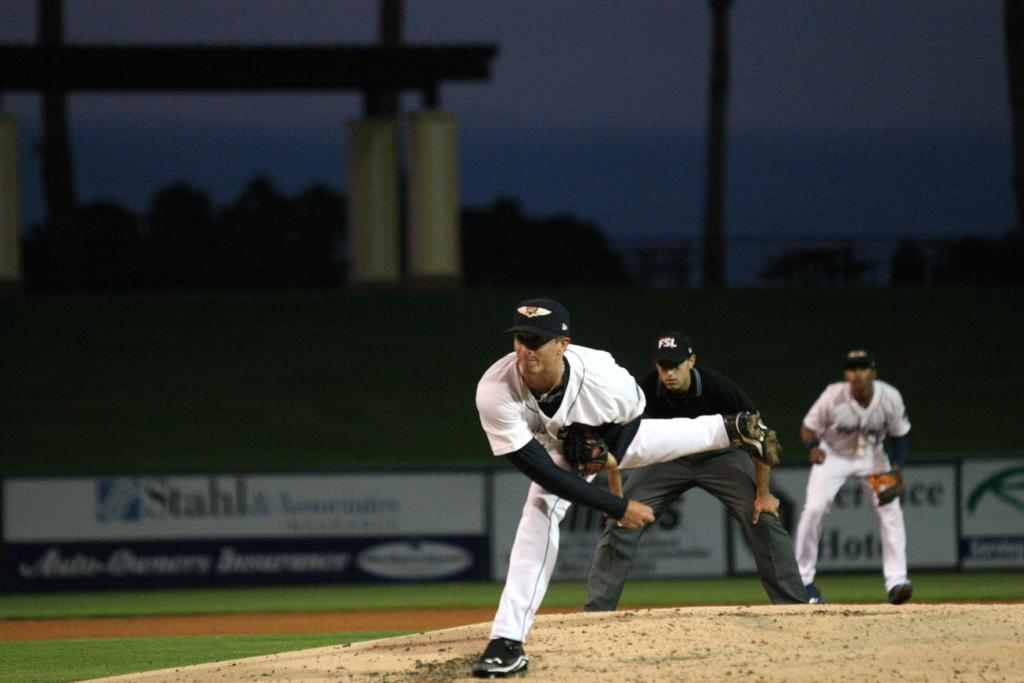What is on the umpire's hat?
Your answer should be compact. Fsl. 